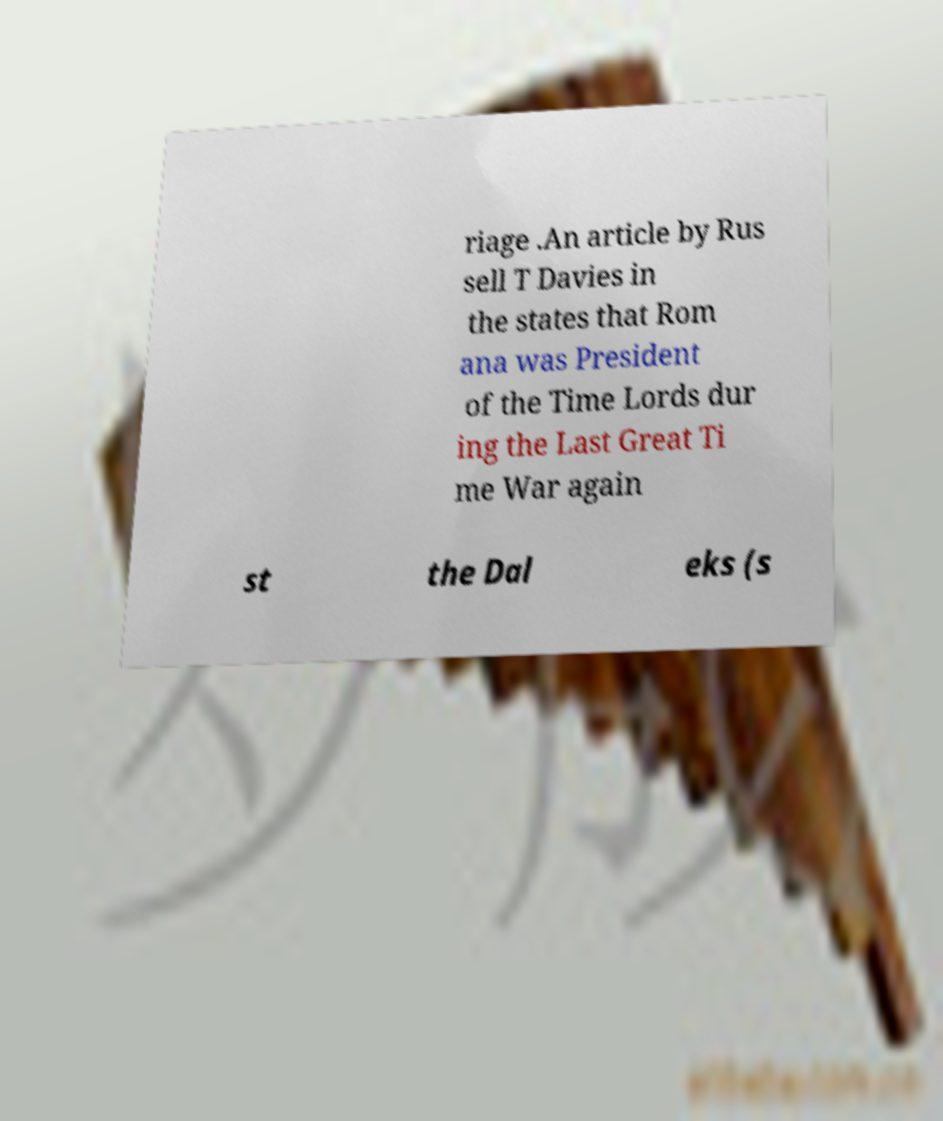Can you accurately transcribe the text from the provided image for me? riage .An article by Rus sell T Davies in the states that Rom ana was President of the Time Lords dur ing the Last Great Ti me War again st the Dal eks (s 